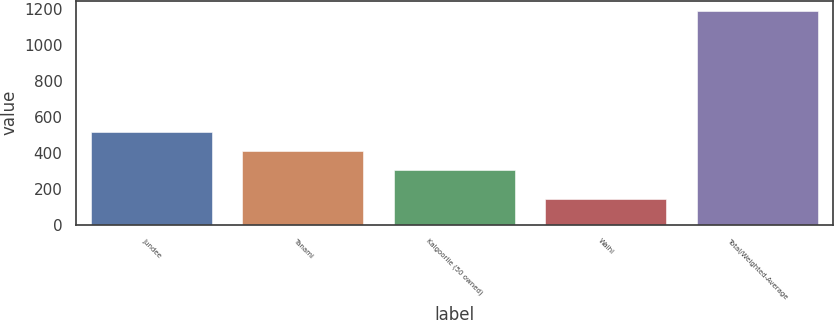Convert chart to OTSL. <chart><loc_0><loc_0><loc_500><loc_500><bar_chart><fcel>Jundee<fcel>Tanami<fcel>Kalgoorlie (50 owned)<fcel>Waihi<fcel>Total/Weighted-Average<nl><fcel>513.2<fcel>408.6<fcel>304<fcel>141<fcel>1187<nl></chart> 